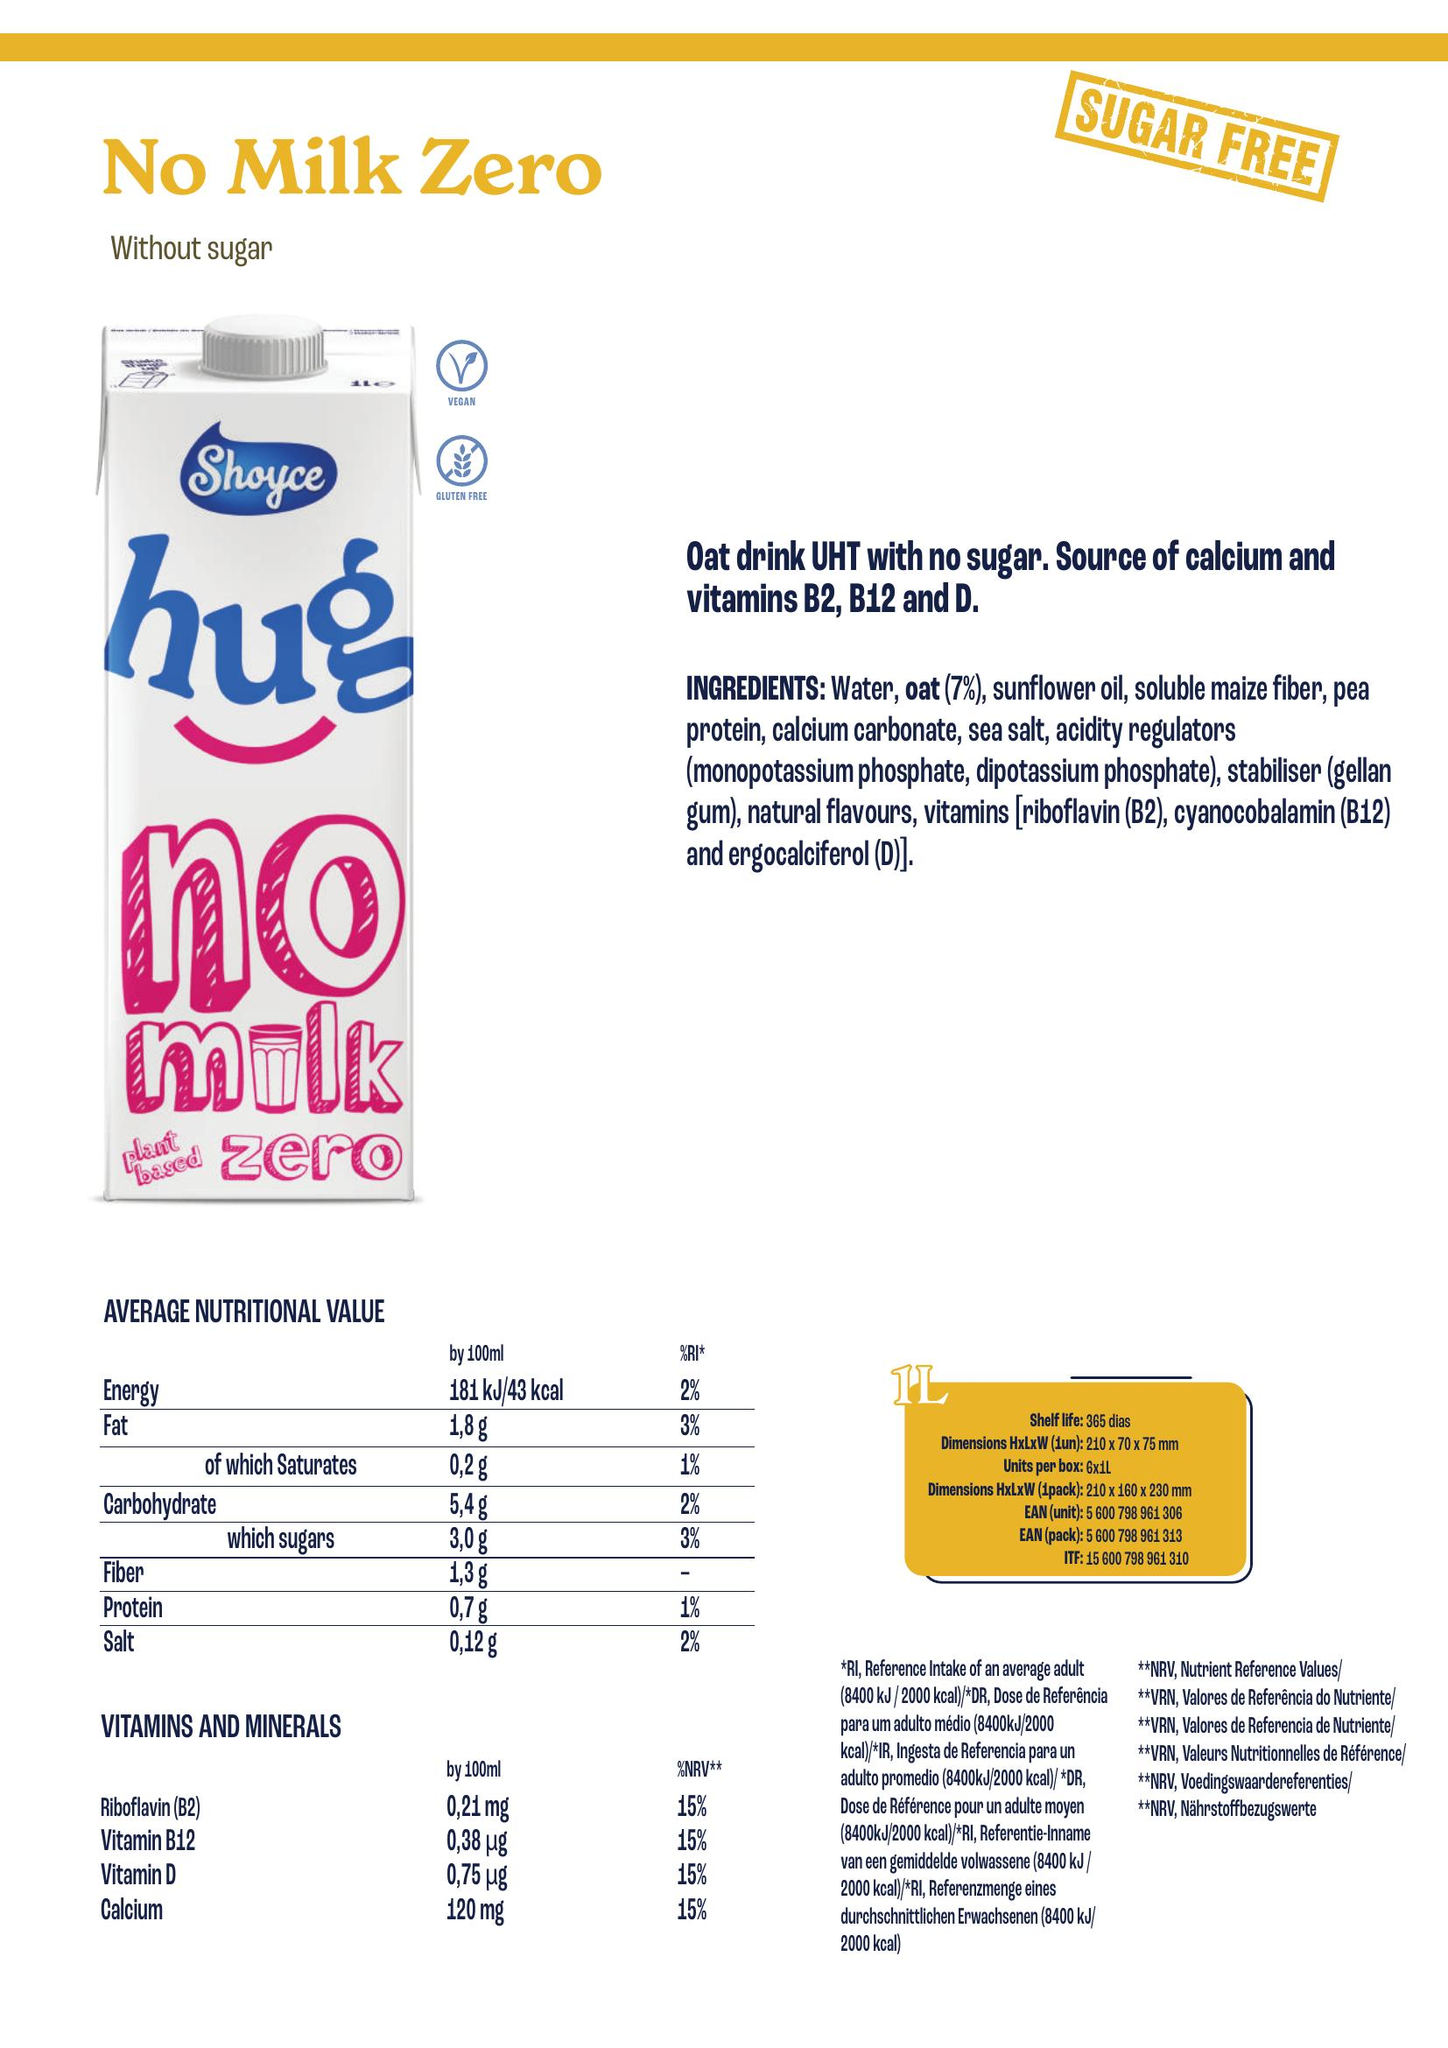From the image, create a nutrition table include as columns the different nutrient present, add the unit associated with the nutrient and append the volume considered for the values in [] after the nutrient name, for energy only consider the information for kcal and isolate the associate value accordingly. Add a column for the product name located in the top left, add a column for the ingredients associated with the product, also add a column for allergens which are ingredients in bold listed in the ingredients.  Write the result as python code to build a dataframe
 ```python
import pandas as pd

df = pd.DataFrame({
    'Product Name': ['No Milk Zero'],
    'Ingredients': ['Water, oat (7%), sunflower oil, soluble maize fiber, pea protein, calcium carbonate, sea salt, acidity regulators (monopotassium phosphate, dipotassium phosphate), stabiliser (gellan gum), natural flavours, vitamins [riboflavin (B2), cyanocobalamin (B12) and ergocalciferol (D)]'],
    'Allergens': ['oat (7%)', 'pea protein', 'gellan gum'],
    'Energy [kcal]': [43],
    'Fat [g]': [1.8],
    'of which Saturates [g]': [0.2],
    'Carbohydrate [g]': [5.4],
    'which sugars [g]': [3.0],
    'Fiber [g]': [1.3],
    'Protein [g]': [0.7],
    'Salt [g]': [0.12],
    'Riboflavin (B2) [mg]': [0.21],
    'Vitamin B12 [µg]': [0.38],
    'Vitamin D [µg]': [0.75],
    'Calcium [mg]': [120]
})
print(df)
``` 